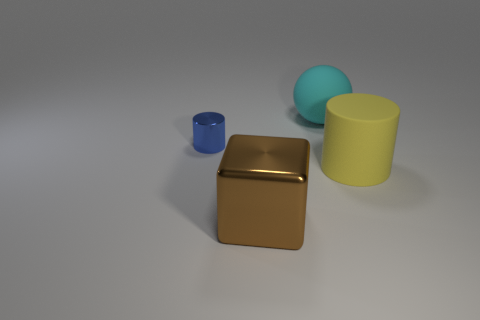Add 3 big yellow matte cylinders. How many objects exist? 7 Subtract all red balls. Subtract all green cylinders. How many balls are left? 1 Subtract all cubes. How many objects are left? 3 Add 3 small cylinders. How many small cylinders are left? 4 Add 2 cyan spheres. How many cyan spheres exist? 3 Subtract 0 red cylinders. How many objects are left? 4 Subtract all cyan rubber things. Subtract all small metal things. How many objects are left? 2 